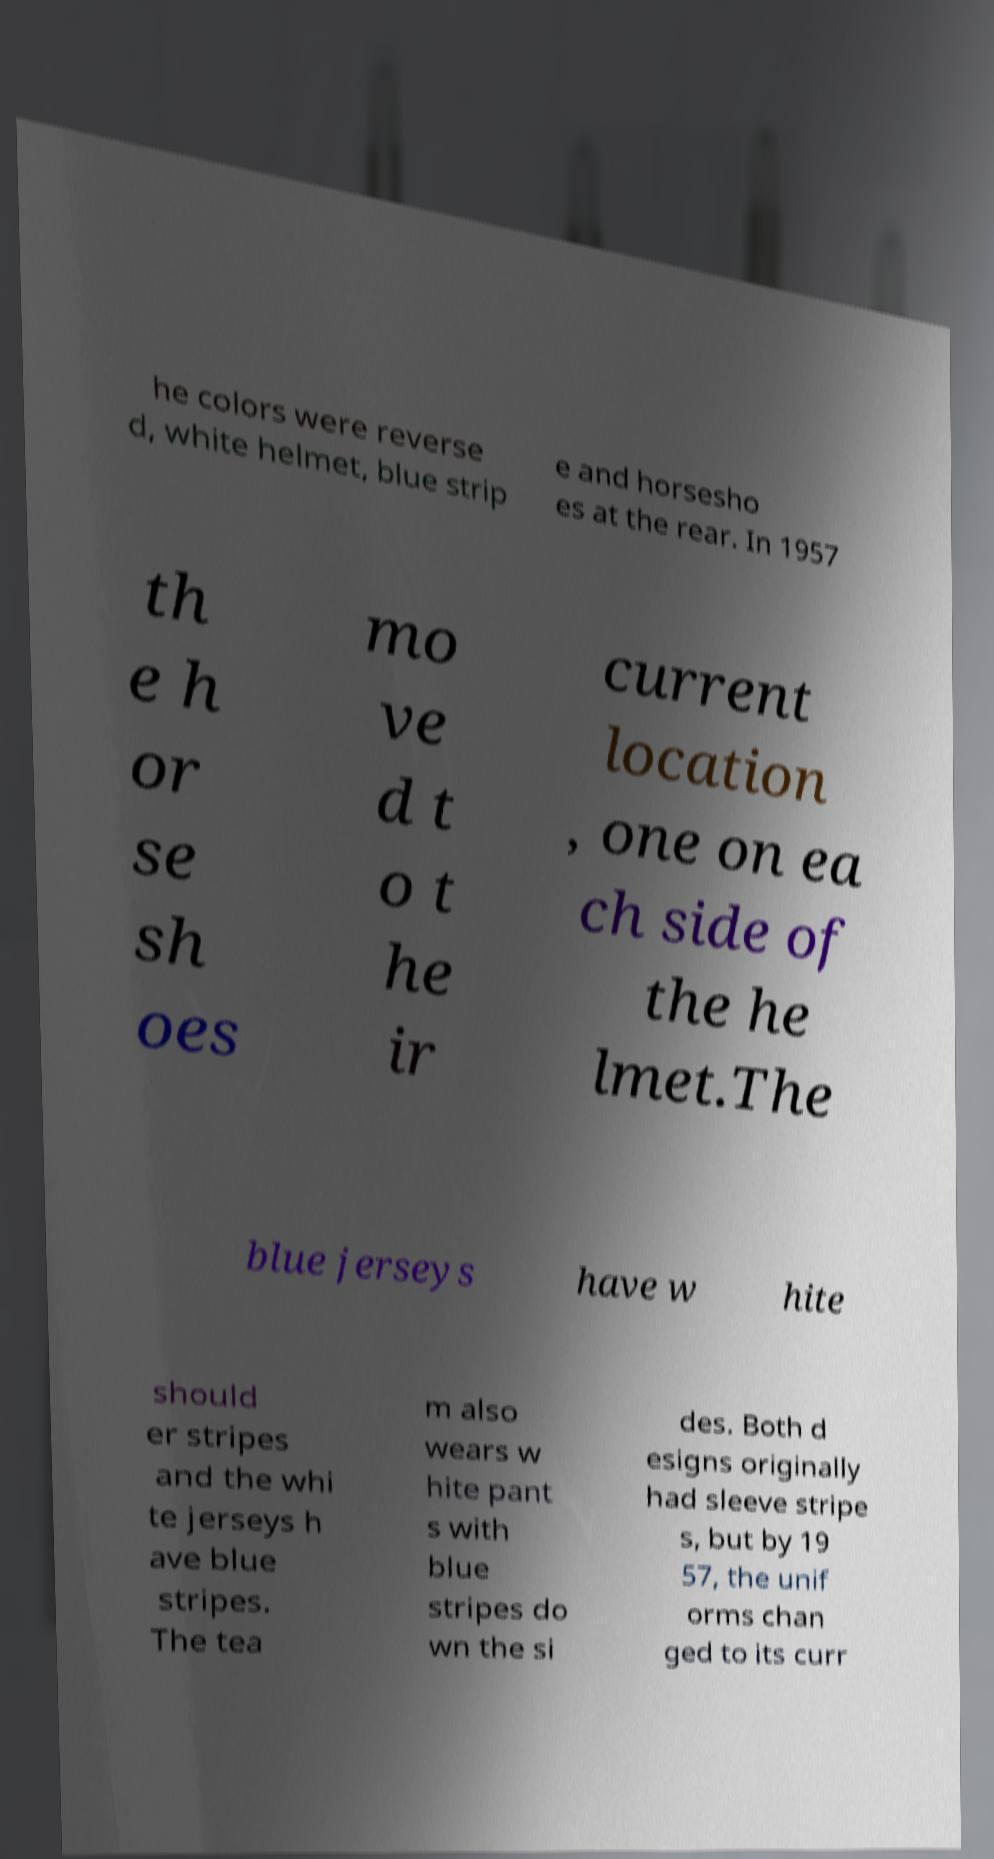Could you assist in decoding the text presented in this image and type it out clearly? he colors were reverse d, white helmet, blue strip e and horsesho es at the rear. In 1957 th e h or se sh oes mo ve d t o t he ir current location , one on ea ch side of the he lmet.The blue jerseys have w hite should er stripes and the whi te jerseys h ave blue stripes. The tea m also wears w hite pant s with blue stripes do wn the si des. Both d esigns originally had sleeve stripe s, but by 19 57, the unif orms chan ged to its curr 